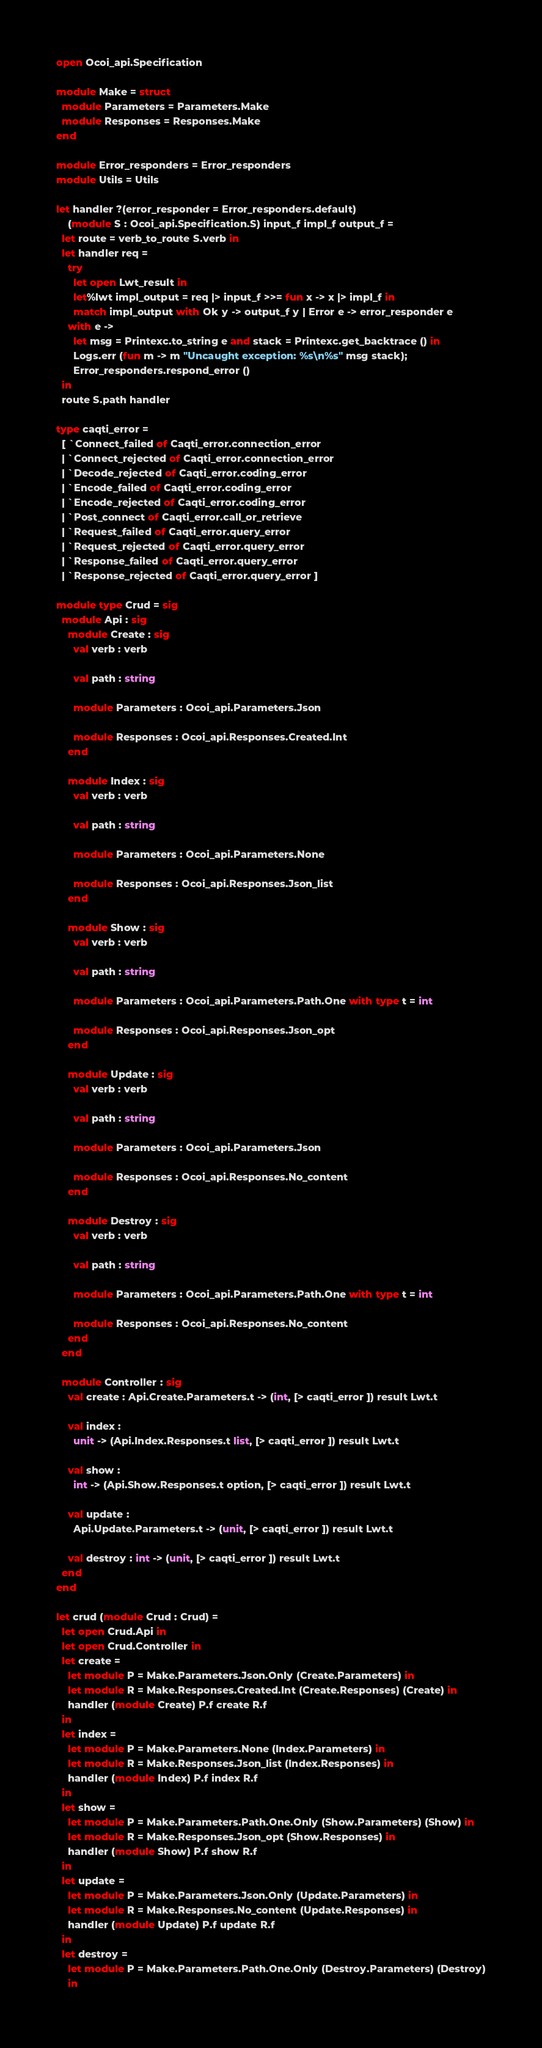Convert code to text. <code><loc_0><loc_0><loc_500><loc_500><_OCaml_>open Ocoi_api.Specification

module Make = struct
  module Parameters = Parameters.Make
  module Responses = Responses.Make
end

module Error_responders = Error_responders
module Utils = Utils

let handler ?(error_responder = Error_responders.default)
    (module S : Ocoi_api.Specification.S) input_f impl_f output_f =
  let route = verb_to_route S.verb in
  let handler req =
    try
      let open Lwt_result in
      let%lwt impl_output = req |> input_f >>= fun x -> x |> impl_f in
      match impl_output with Ok y -> output_f y | Error e -> error_responder e
    with e ->
      let msg = Printexc.to_string e and stack = Printexc.get_backtrace () in
      Logs.err (fun m -> m "Uncaught exception: %s\n%s" msg stack);
      Error_responders.respond_error ()
  in
  route S.path handler

type caqti_error =
  [ `Connect_failed of Caqti_error.connection_error
  | `Connect_rejected of Caqti_error.connection_error
  | `Decode_rejected of Caqti_error.coding_error
  | `Encode_failed of Caqti_error.coding_error
  | `Encode_rejected of Caqti_error.coding_error
  | `Post_connect of Caqti_error.call_or_retrieve
  | `Request_failed of Caqti_error.query_error
  | `Request_rejected of Caqti_error.query_error
  | `Response_failed of Caqti_error.query_error
  | `Response_rejected of Caqti_error.query_error ]

module type Crud = sig
  module Api : sig
    module Create : sig
      val verb : verb

      val path : string

      module Parameters : Ocoi_api.Parameters.Json

      module Responses : Ocoi_api.Responses.Created.Int
    end

    module Index : sig
      val verb : verb

      val path : string

      module Parameters : Ocoi_api.Parameters.None

      module Responses : Ocoi_api.Responses.Json_list
    end

    module Show : sig
      val verb : verb

      val path : string

      module Parameters : Ocoi_api.Parameters.Path.One with type t = int

      module Responses : Ocoi_api.Responses.Json_opt
    end

    module Update : sig
      val verb : verb

      val path : string

      module Parameters : Ocoi_api.Parameters.Json

      module Responses : Ocoi_api.Responses.No_content
    end

    module Destroy : sig
      val verb : verb

      val path : string

      module Parameters : Ocoi_api.Parameters.Path.One with type t = int

      module Responses : Ocoi_api.Responses.No_content
    end
  end

  module Controller : sig
    val create : Api.Create.Parameters.t -> (int, [> caqti_error ]) result Lwt.t

    val index :
      unit -> (Api.Index.Responses.t list, [> caqti_error ]) result Lwt.t

    val show :
      int -> (Api.Show.Responses.t option, [> caqti_error ]) result Lwt.t

    val update :
      Api.Update.Parameters.t -> (unit, [> caqti_error ]) result Lwt.t

    val destroy : int -> (unit, [> caqti_error ]) result Lwt.t
  end
end

let crud (module Crud : Crud) =
  let open Crud.Api in
  let open Crud.Controller in
  let create =
    let module P = Make.Parameters.Json.Only (Create.Parameters) in
    let module R = Make.Responses.Created.Int (Create.Responses) (Create) in
    handler (module Create) P.f create R.f
  in
  let index =
    let module P = Make.Parameters.None (Index.Parameters) in
    let module R = Make.Responses.Json_list (Index.Responses) in
    handler (module Index) P.f index R.f
  in
  let show =
    let module P = Make.Parameters.Path.One.Only (Show.Parameters) (Show) in
    let module R = Make.Responses.Json_opt (Show.Responses) in
    handler (module Show) P.f show R.f
  in
  let update =
    let module P = Make.Parameters.Json.Only (Update.Parameters) in
    let module R = Make.Responses.No_content (Update.Responses) in
    handler (module Update) P.f update R.f
  in
  let destroy =
    let module P = Make.Parameters.Path.One.Only (Destroy.Parameters) (Destroy)
    in</code> 